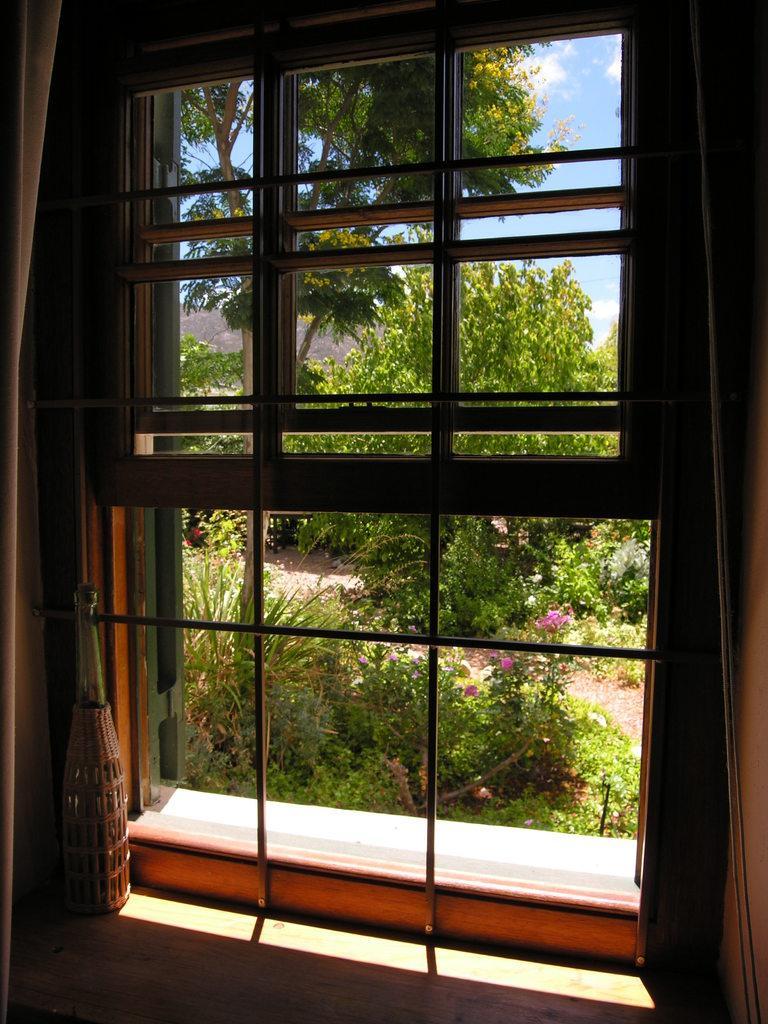Can you describe this image briefly? In the image we can see a window and a bottle. Out of the window we can see grass, plant, tree and a sky. 